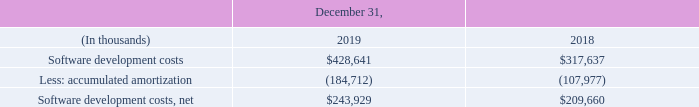Software Development Costs
We capitalize purchased software upon acquisition if it is accounted for as internal-use software or if it meets the future alternative use criteria. We capitalize incurred labor costs for software development from the time technological feasibility of the software is established, or when the preliminary project phase is completed in the case of internal-use software, until the software is available for general release. Research and development costs and other computer software maintenance costs related to software development are expensed as incurred.
We estimate the useful life of our capitalized software and amortize its value over that estimated life. If the actual useful life is shorter than our estimated useful life, we will amortize the remaining book value over the remaining useful life or the asset may be deemed to be impaired and, accordingly, a write-down of the value of the asset may be recorded as a charge to earnings.
Upon the availability for general release, we commence amortization of the capitalized software costs on a product by product basis. Amortization of capitalized software is recorded using the greater of (i) the ratio of current revenues to total and anticipated future revenues for the applicable product or (ii) the straightline method over the remaining estimated economic life, which is estimated to be three to five years.
At each balance sheet date, the unamortized capitalized costs of a software product are compared with the net realizable value of that product. The net realizable value is the estimated future gross revenues from that product reduced by the estimated future costs of completing and disposing of that product, including the costs of performing maintenance and client support required to satisfy our responsibility set forth at the time of sale.
The amount by which the unamortized capitalized costs of a software product exceed the net realizable value of that asset is written off. If we determine that the value of the capitalized software could not be recovered, a write-down of the value of the capitalized software to its recoverable value is recorded as a charge to earnings. The unamortized balances of capitalized software were as follows:
When is the purchased software capitalized? Upon acquisition if it is accounted for as internal-use software or if it meets the future alternative use criteria. How is the amortization of capitalized software recorded? Using the greater of (i) the ratio of current revenues to total and anticipated future revenues for the applicable product or (ii) the straightline method over the remaining estimated economic life, which is estimated to be three to five years. What is the Software development costs in 2019?
Answer scale should be: thousand. $428,641. What is the change in the Software development costs from 2018 to 2019?
Answer scale should be: thousand. 428,641 - 317,637
Answer: 111004. What is the average accumulated amortization for 2018 and 2019?
Answer scale should be: thousand. -(184,712 + 107,977) / 2
Answer: -146344.5. What is the percentage change in Software development costs, net from 2018 to 2019?
Answer scale should be: percent. 243,929 / 209,660 - 1
Answer: 0.16. 